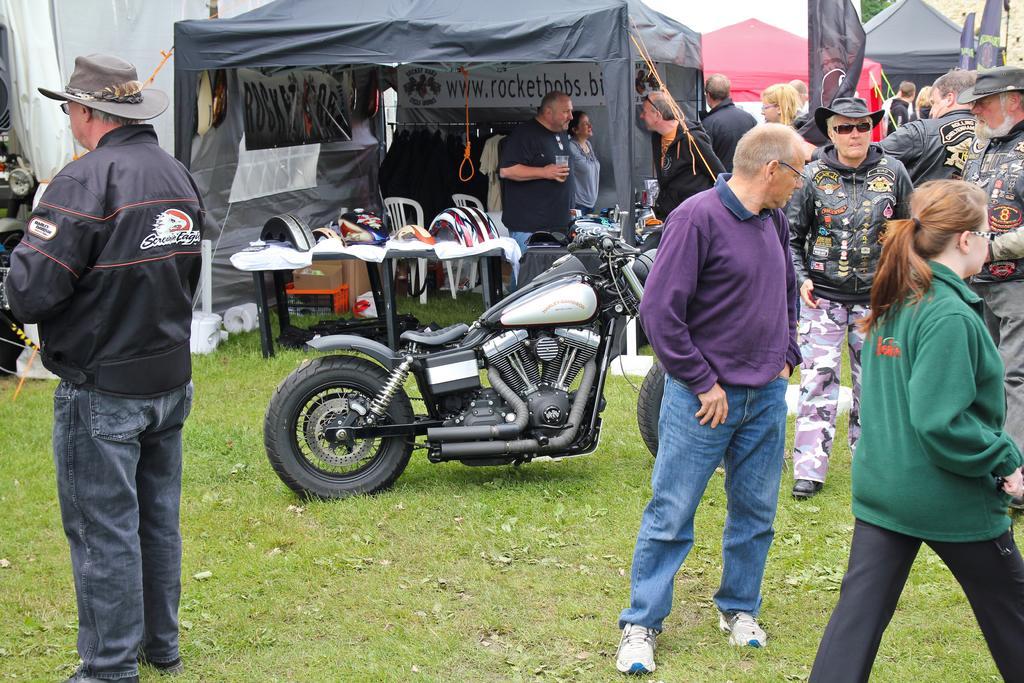How would you summarize this image in a sentence or two? In this image we can see a group of people standing on the ground. One person wearing a jacket and a hat. To the right side of the image we can see a woman wearing spectacles and a green jacket. In the background, we can see a vehicle parked on the ground, group of tents, chairs and tables. 